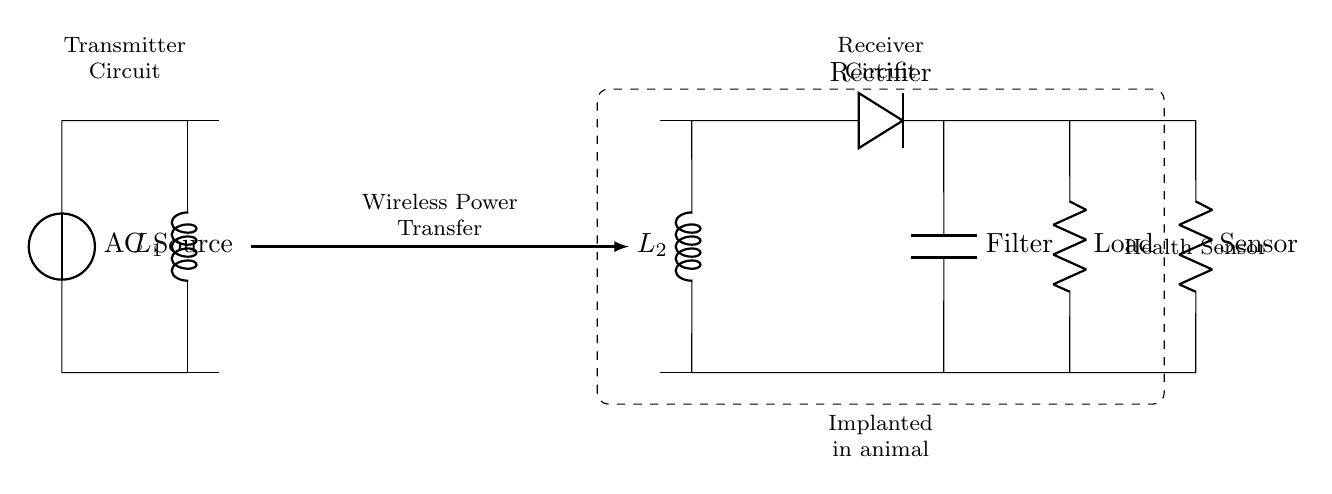What are the two main parts of the circuit? The circuit consists of a transmitter circuit and a receiver circuit, as labeled in the diagram.
Answer: Transmitter circuit, Receiver circuit What component converts AC to DC in the receiver circuit? The rectifier, indicated by the symbol D, converts alternating current from the receiver coil into direct current.
Answer: Rectifier What is the purpose of the filter in the circuit? The filter, represented by the symbol C, smooths the output from the rectifier by reducing voltage ripples, providing a steady DC voltage to the load.
Answer: To smooth rectified output How does power transfer occur in this circuit? Power is transferred wirelessly through inductive coupling between the transmitter coil and receiver coil, as shown by the arrow between them.
Answer: Wireless Power Transfer What is the load component in the receiver circuit? The load is represented by the resistor symbol R, which indicates where the voltage is used or drawn in the circuit.
Answer: Load What animal implant is represented in this circuit? The diagram includes a health sensor, which is used for monitoring the animal's health as indicated in the component list of the circuit.
Answer: Health Sensor What type of energy does the AC source provide? The AC source supplies alternating electrical energy necessary for the wireless charging process.
Answer: Alternating Electrical Energy 